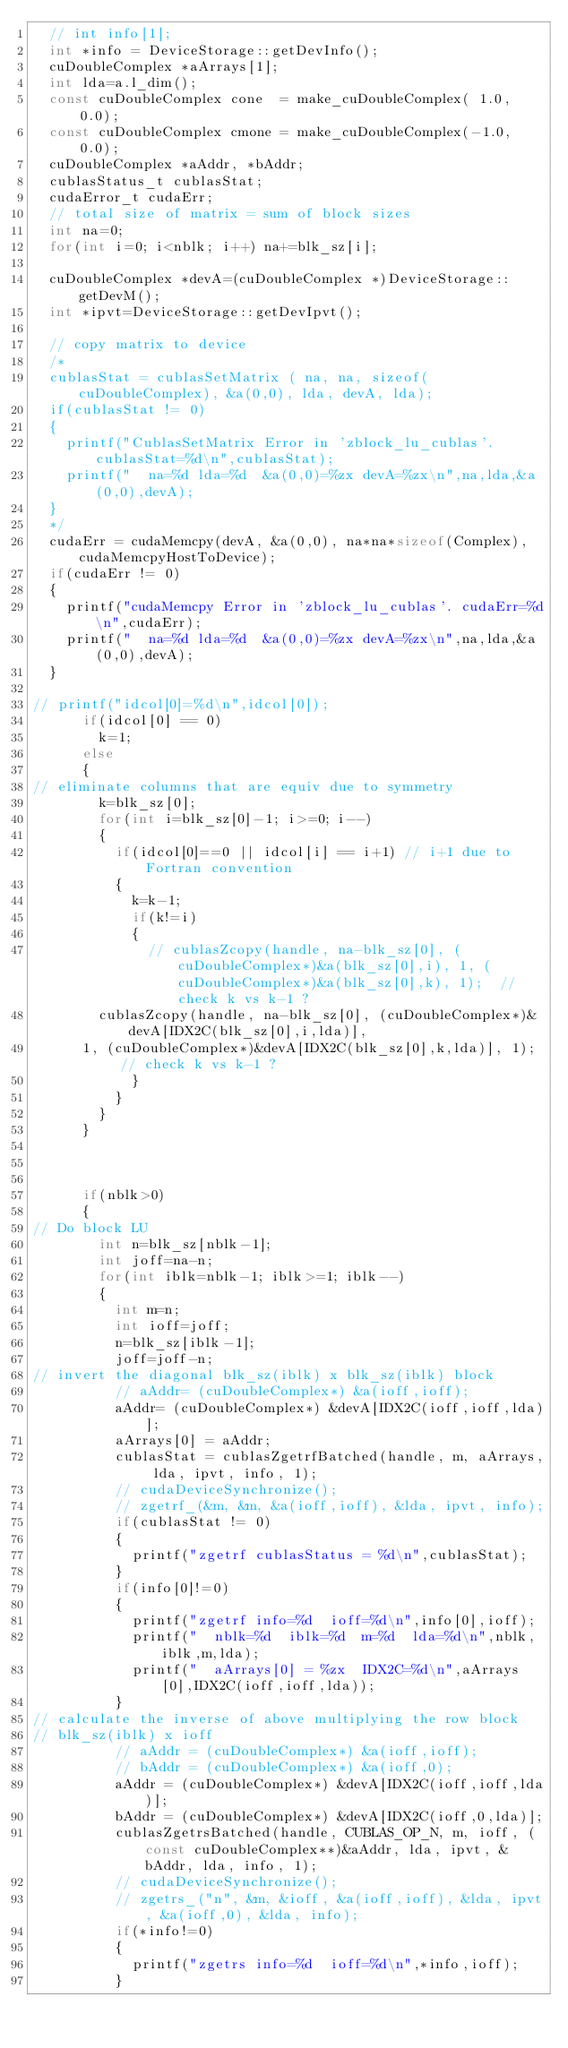Convert code to text. <code><loc_0><loc_0><loc_500><loc_500><_C++_>  // int info[1];
  int *info = DeviceStorage::getDevInfo();
  cuDoubleComplex *aArrays[1];
  int lda=a.l_dim();
  const cuDoubleComplex cone  = make_cuDoubleComplex( 1.0, 0.0);
  const cuDoubleComplex cmone = make_cuDoubleComplex(-1.0, 0.0);
  cuDoubleComplex *aAddr, *bAddr;
  cublasStatus_t cublasStat;
  cudaError_t cudaErr;
  // total size of matrix = sum of block sizes
  int na=0;
  for(int i=0; i<nblk; i++) na+=blk_sz[i];

  cuDoubleComplex *devA=(cuDoubleComplex *)DeviceStorage::getDevM();
  int *ipvt=DeviceStorage::getDevIpvt();

  // copy matrix to device 
  /*
  cublasStat = cublasSetMatrix ( na, na, sizeof(cuDoubleComplex), &a(0,0), lda, devA, lda);
  if(cublasStat != 0)
  {
    printf("CublasSetMatrix Error in 'zblock_lu_cublas'. cublasStat=%d\n",cublasStat);
    printf("  na=%d lda=%d  &a(0,0)=%zx devA=%zx\n",na,lda,&a(0,0),devA);
  }
  */
  cudaErr = cudaMemcpy(devA, &a(0,0), na*na*sizeof(Complex), cudaMemcpyHostToDevice);
  if(cudaErr != 0)
  {
    printf("cudaMemcpy Error in 'zblock_lu_cublas'. cudaErr=%d\n",cudaErr);
    printf("  na=%d lda=%d  &a(0,0)=%zx devA=%zx\n",na,lda,&a(0,0),devA);
  }

// printf("idcol[0]=%d\n",idcol[0]);
      if(idcol[0] == 0)
        k=1;
      else
      {
// eliminate columns that are equiv due to symmetry
        k=blk_sz[0];
        for(int i=blk_sz[0]-1; i>=0; i--)
        {
          if(idcol[0]==0 || idcol[i] == i+1) // i+1 due to Fortran convention
          {
            k=k-1;
            if(k!=i)
            {
              // cublasZcopy(handle, na-blk_sz[0], (cuDoubleComplex*)&a(blk_sz[0],i), 1, (cuDoubleComplex*)&a(blk_sz[0],k), 1);  // check k vs k-1 ?
	      cublasZcopy(handle, na-blk_sz[0], (cuDoubleComplex*)&devA[IDX2C(blk_sz[0],i,lda)],
		  1, (cuDoubleComplex*)&devA[IDX2C(blk_sz[0],k,lda)], 1);  // check k vs k-1 ?
            }
          }
        }
      }

  

      if(nblk>0)
      {
// Do block LU
        int n=blk_sz[nblk-1];
        int joff=na-n;
        for(int iblk=nblk-1; iblk>=1; iblk--)
        {
          int m=n;
          int ioff=joff;
          n=blk_sz[iblk-1];
          joff=joff-n;
// invert the diagonal blk_sz(iblk) x blk_sz(iblk) block
          // aAddr= (cuDoubleComplex*) &a(ioff,ioff);
          aAddr= (cuDoubleComplex*) &devA[IDX2C(ioff,ioff,lda)];
          aArrays[0] = aAddr;
          cublasStat = cublasZgetrfBatched(handle, m, aArrays, lda, ipvt, info, 1);
          // cudaDeviceSynchronize();
          // zgetrf_(&m, &m, &a(ioff,ioff), &lda, ipvt, info); 
          if(cublasStat != 0)
          {
            printf("zgetrf cublasStatus = %d\n",cublasStat);
          }
          if(info[0]!=0)
          {
            printf("zgetrf info=%d  ioff=%d\n",info[0],ioff);
            printf("  nblk=%d  iblk=%d  m=%d  lda=%d\n",nblk,iblk,m,lda);
            printf("  aArrays[0] = %zx  IDX2C=%d\n",aArrays[0],IDX2C(ioff,ioff,lda));
          }
// calculate the inverse of above multiplying the row block
// blk_sz(iblk) x ioff
          // aAddr = (cuDoubleComplex*) &a(ioff,ioff);
          // bAddr = (cuDoubleComplex*) &a(ioff,0);
          aAddr = (cuDoubleComplex*) &devA[IDX2C(ioff,ioff,lda)];
          bAddr = (cuDoubleComplex*) &devA[IDX2C(ioff,0,lda)];
          cublasZgetrsBatched(handle, CUBLAS_OP_N, m, ioff, (const cuDoubleComplex**)&aAddr, lda, ipvt, &bAddr, lda, info, 1);
          // cudaDeviceSynchronize();
          // zgetrs_("n", &m, &ioff, &a(ioff,ioff), &lda, ipvt, &a(ioff,0), &lda, info);
          if(*info!=0)
          {
            printf("zgetrs info=%d  ioff=%d\n",*info,ioff);
          }</code> 